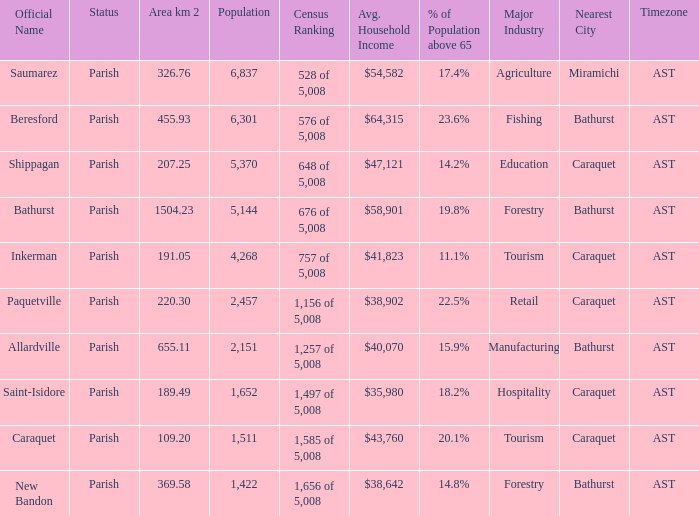What is the Population of the New Bandon Parish with an Area km 2 larger than 326.76? 1422.0. 